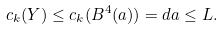Convert formula to latex. <formula><loc_0><loc_0><loc_500><loc_500>c _ { k } ( Y ) \leq c _ { k } ( B ^ { 4 } ( a ) ) = d a \leq L .</formula> 